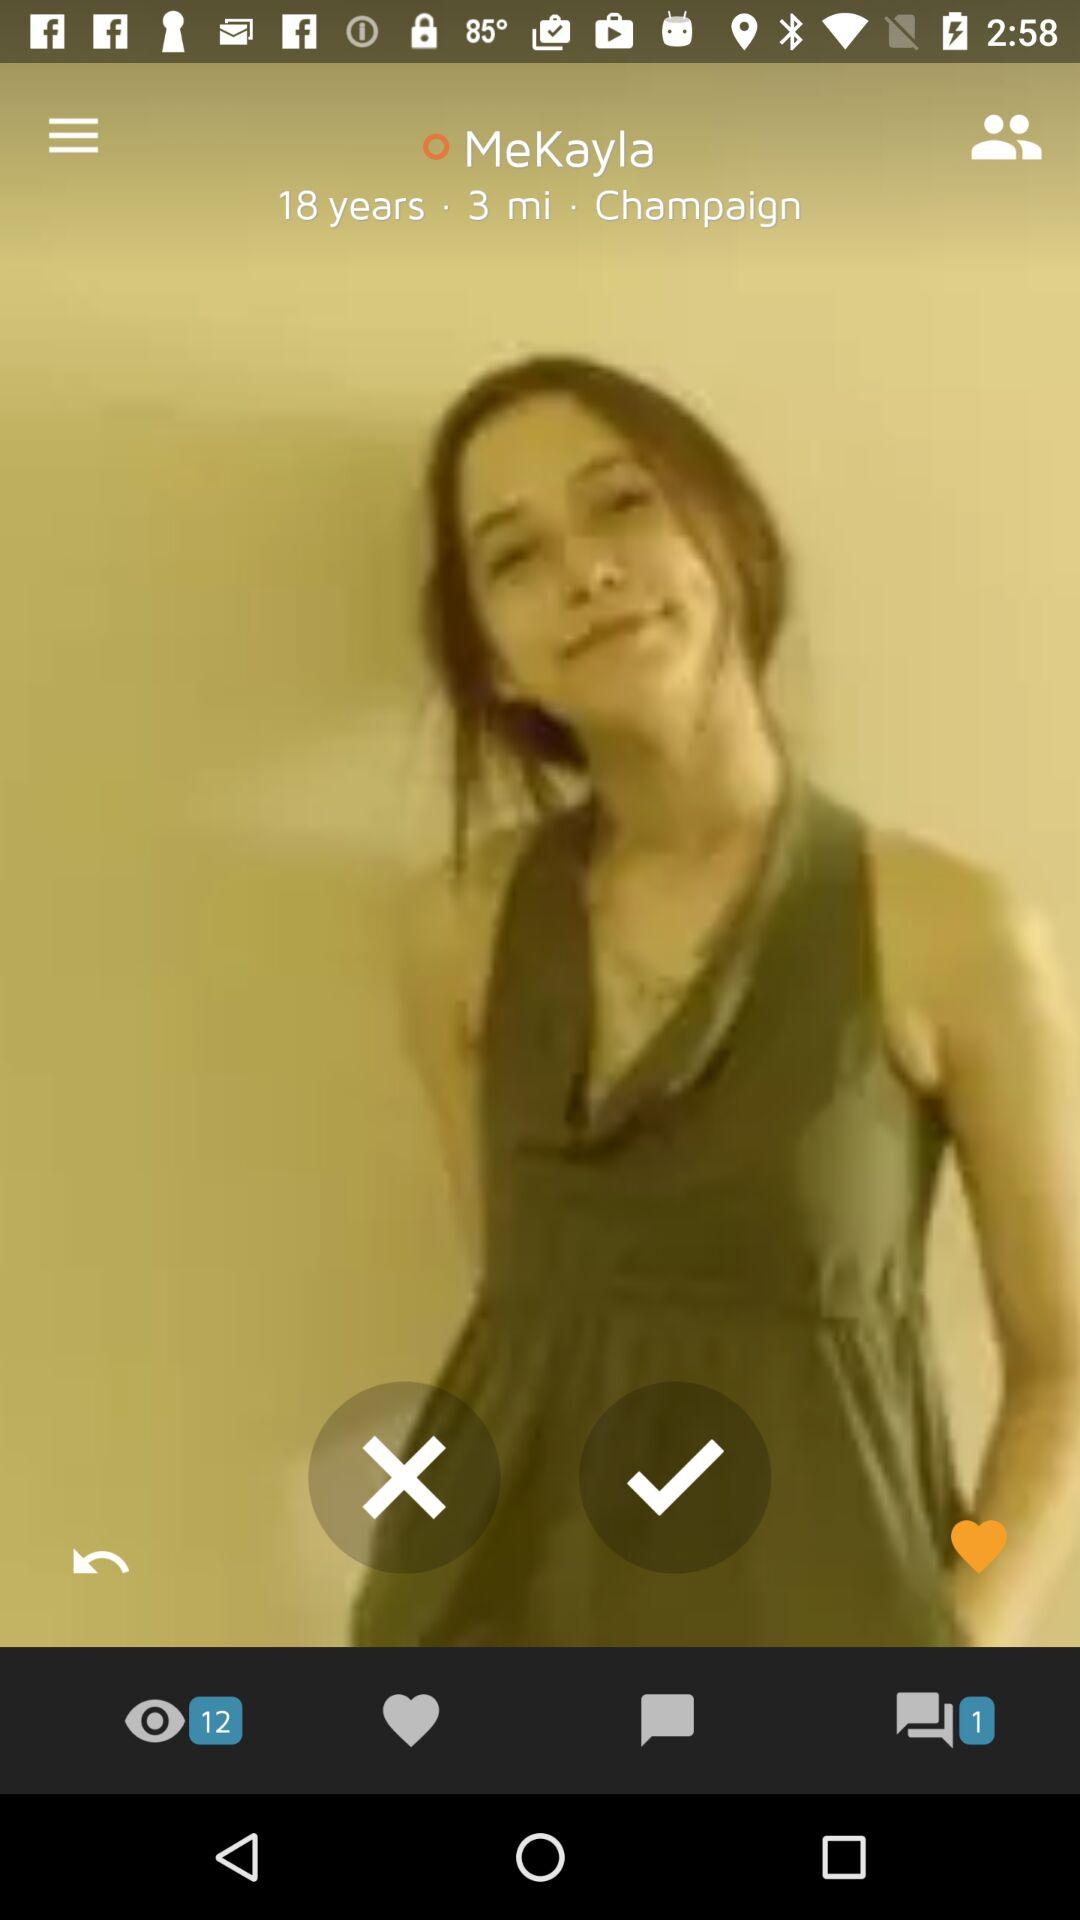Is there any unread chat?
When the provided information is insufficient, respond with <no answer>. <no answer> 